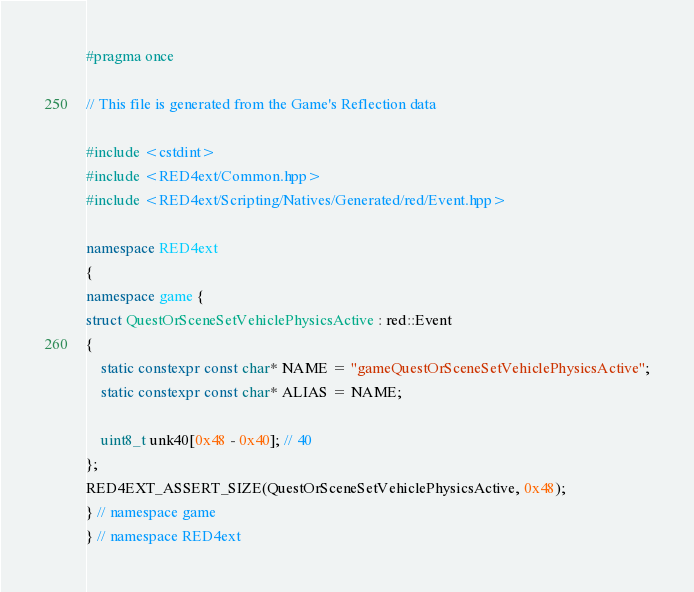Convert code to text. <code><loc_0><loc_0><loc_500><loc_500><_C++_>#pragma once

// This file is generated from the Game's Reflection data

#include <cstdint>
#include <RED4ext/Common.hpp>
#include <RED4ext/Scripting/Natives/Generated/red/Event.hpp>

namespace RED4ext
{
namespace game { 
struct QuestOrSceneSetVehiclePhysicsActive : red::Event
{
    static constexpr const char* NAME = "gameQuestOrSceneSetVehiclePhysicsActive";
    static constexpr const char* ALIAS = NAME;

    uint8_t unk40[0x48 - 0x40]; // 40
};
RED4EXT_ASSERT_SIZE(QuestOrSceneSetVehiclePhysicsActive, 0x48);
} // namespace game
} // namespace RED4ext
</code> 